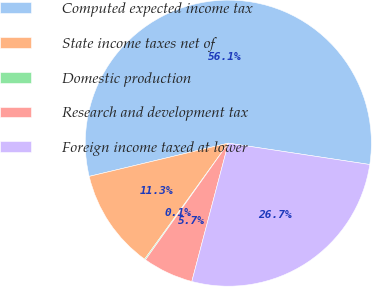Convert chart. <chart><loc_0><loc_0><loc_500><loc_500><pie_chart><fcel>Computed expected income tax<fcel>State income taxes net of<fcel>Domestic production<fcel>Research and development tax<fcel>Foreign income taxed at lower<nl><fcel>56.12%<fcel>11.32%<fcel>0.12%<fcel>5.72%<fcel>26.72%<nl></chart> 